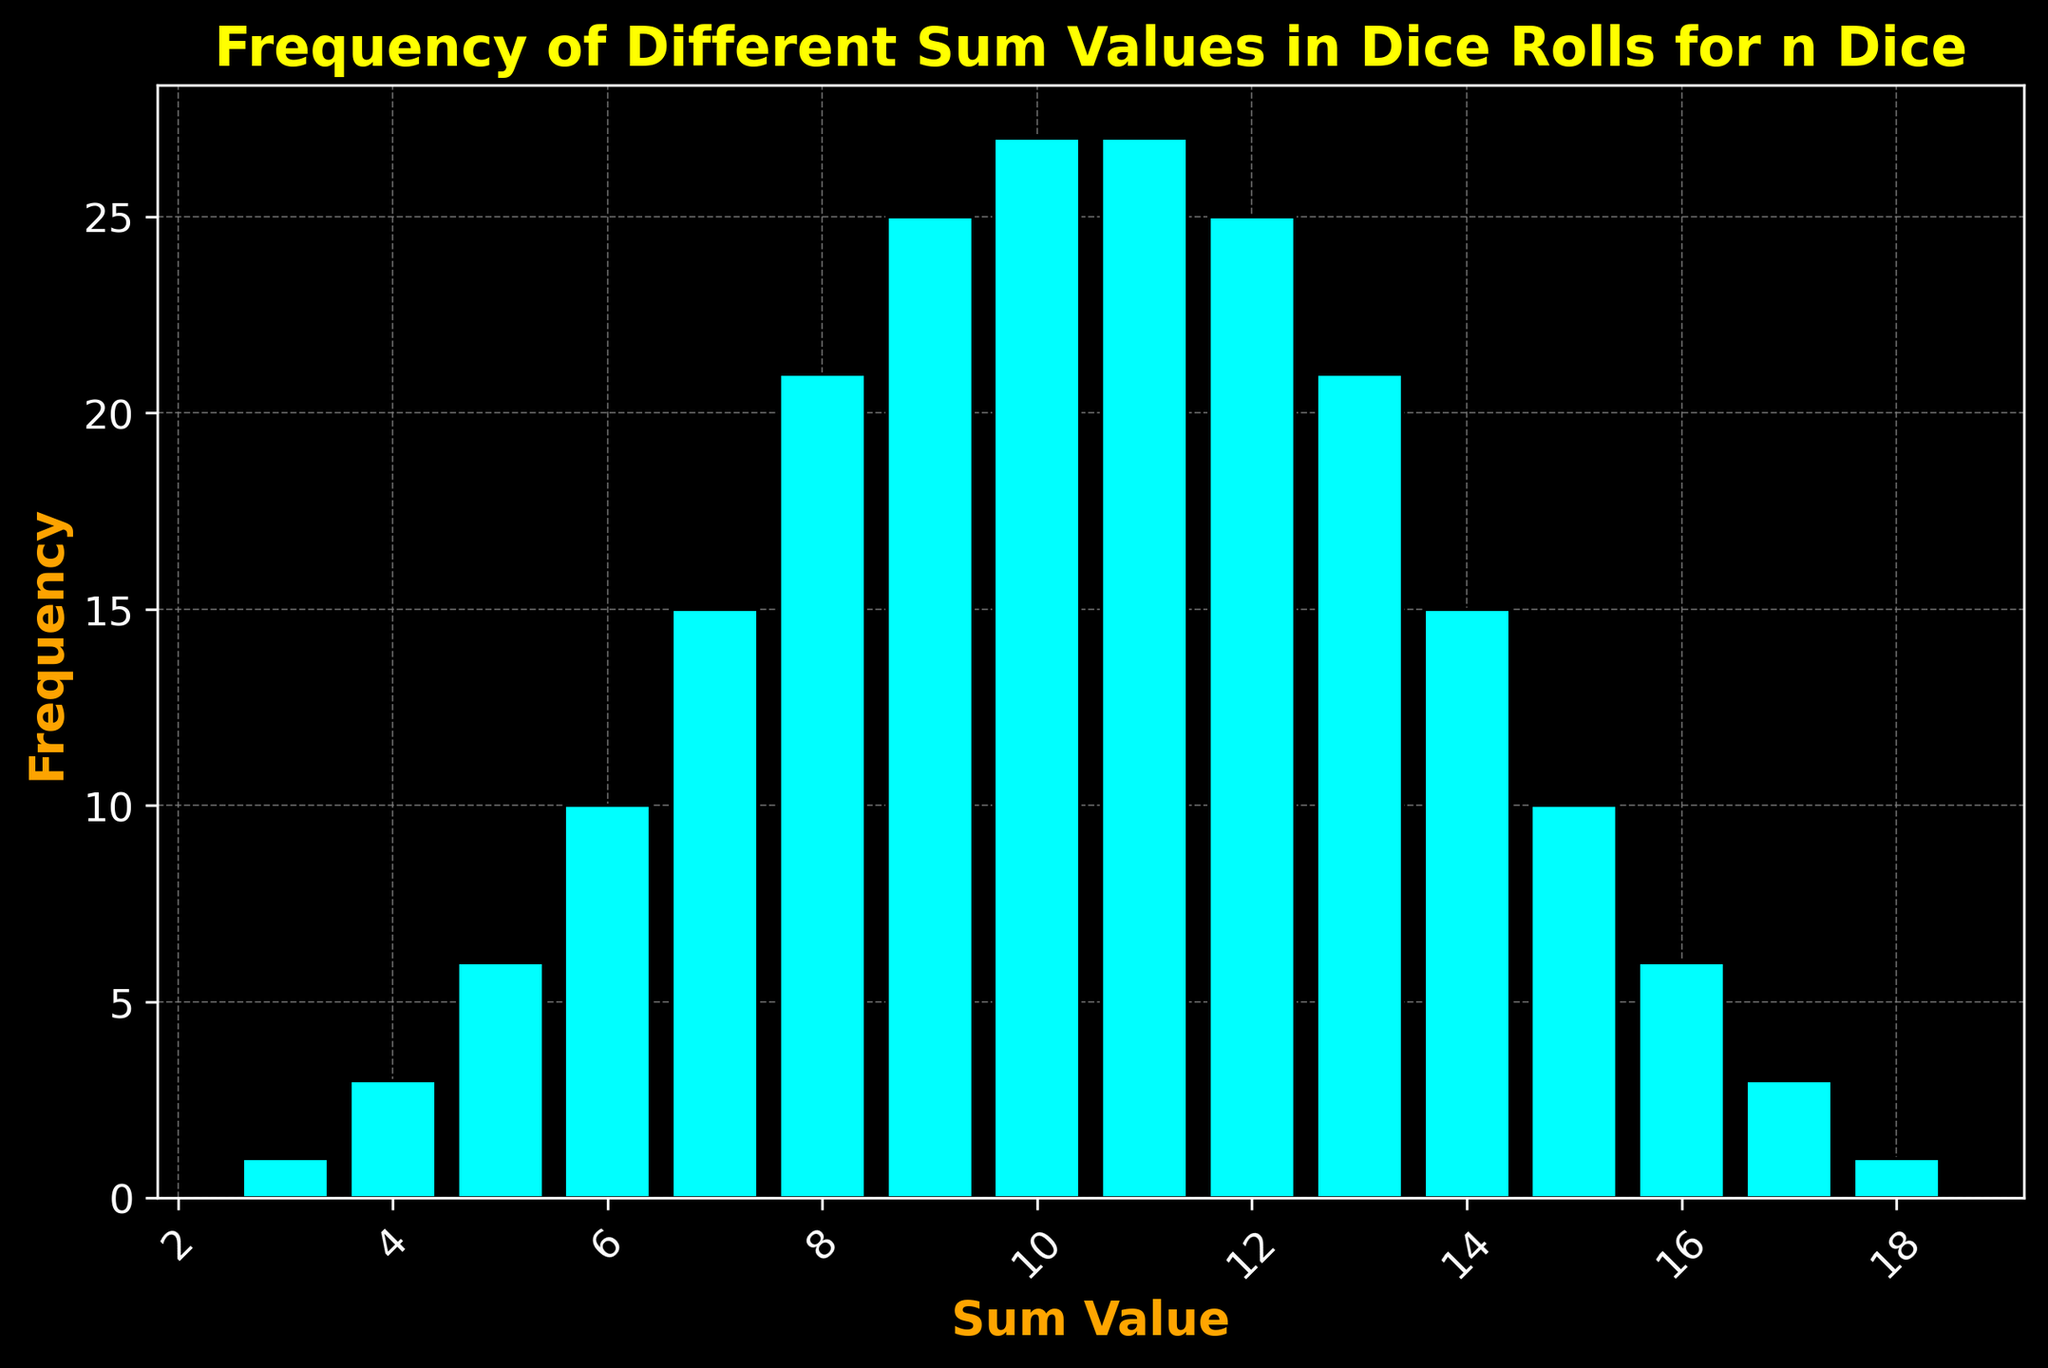What's the most frequent sum value? The bar with the maximum height represents the most frequent sum value. The chart shows that the bar for the sum value of 10 and 11 is the highest, both with a frequency of 27.
Answer: 10 and 11 Which sum value has the least frequency? The shortest bars indicate the least frequency. The chart shows that the bars for the sum values of 3 and 18 are the shortest, both with a frequency of 1.
Answer: 3 and 18 What is the difference in frequency between the sum values 7 and 14? The frequency of sum value 7 is 15, and the frequency of sum value 14 is also 15. The difference is 15 - 15 = 0.
Answer: 0 Which sum values appear more frequently than the sum value of 9? The sum value of 9 has a frequency of 25. The sum values 10 and 11 have frequencies of 27, which are greater than 25.
Answer: 10 and 11 What is the average frequency of the sum values 6, 7, and 8? Sum the frequencies of 6, 7, and 8, which are 10, 15, and 21 respectively. The total is 10 + 15 + 21 = 46. The average is 46/3 = 15.33.
Answer: 15.33 What is the range of the frequencies in the data? The range is the difference between the highest and lowest frequencies. The highest frequency is 27, and the lowest is 1. The range is 27 - 1 = 26.
Answer: 26 Which sum value is the median of the distribution? First, identify the middle value(s) of the frequency distribution. There are 16 sum values, so the middle two frequencies are the 8th and 9th highest. The sum values of 8 and 9 have the middle frequencies: 21 and 25 respectively. The median sum value is between 8 and 9.
Answer: 8 and 9 Which sum value has a frequency exactly equal to the average of the highest and lowest frequencies? The highest frequency is 27, and the lowest frequency is 1. The average is (27 + 1) / 2 = 14. The sum value of 14 has a frequency of 15, which is not 14. No sum value has a frequency of exactly 14.
Answer: None 